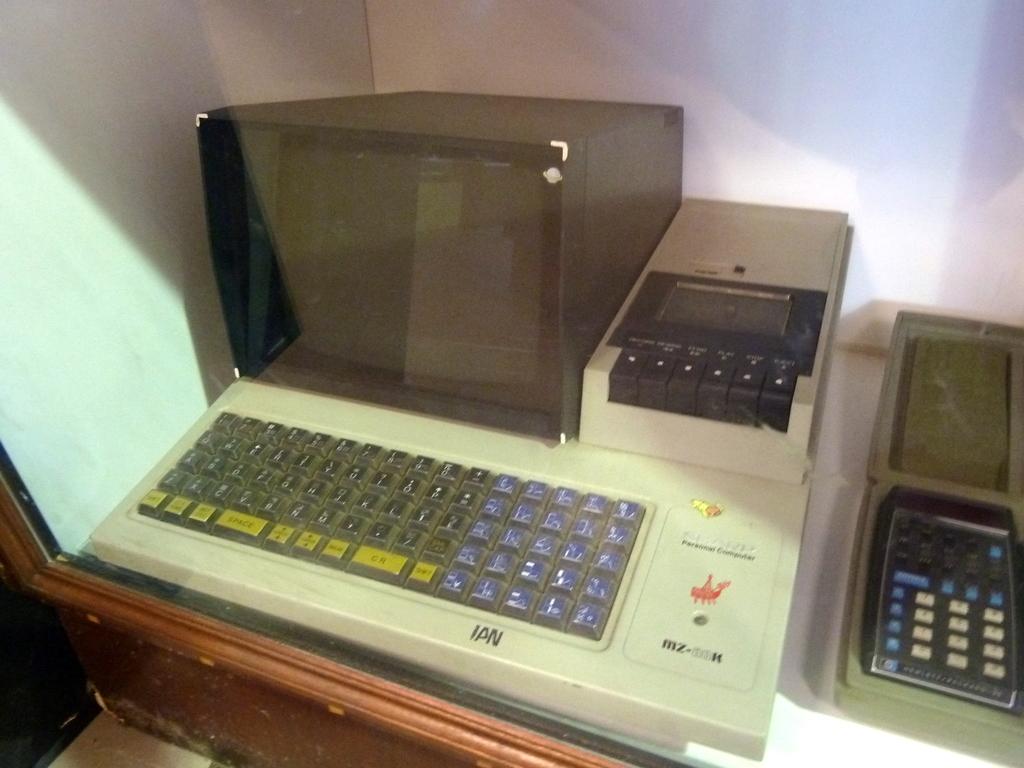What is the name that's scribbled in black below the blue keys?
Your answer should be very brief. Ian. 